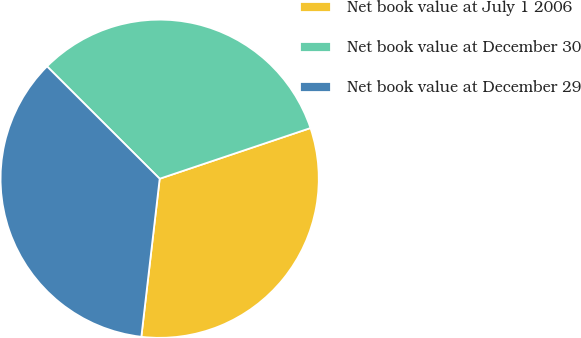Convert chart to OTSL. <chart><loc_0><loc_0><loc_500><loc_500><pie_chart><fcel>Net book value at July 1 2006<fcel>Net book value at December 30<fcel>Net book value at December 29<nl><fcel>32.0%<fcel>32.36%<fcel>35.64%<nl></chart> 